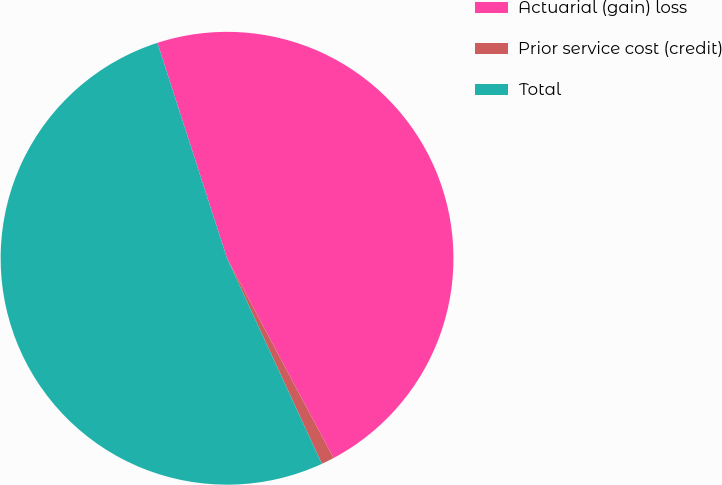Convert chart to OTSL. <chart><loc_0><loc_0><loc_500><loc_500><pie_chart><fcel>Actuarial (gain) loss<fcel>Prior service cost (credit)<fcel>Total<nl><fcel>47.18%<fcel>0.92%<fcel>51.9%<nl></chart> 